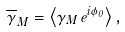Convert formula to latex. <formula><loc_0><loc_0><loc_500><loc_500>\overline { \gamma } _ { M } = \left < \gamma _ { M } \, e ^ { i \phi _ { 0 } } \right > ,</formula> 